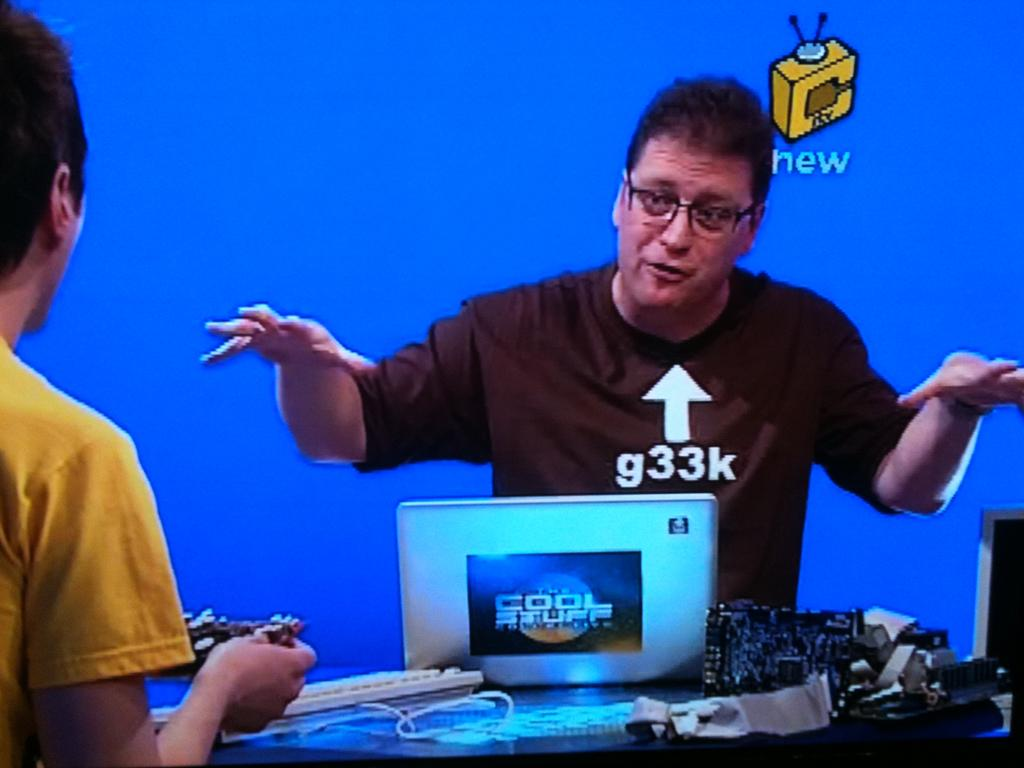Provide a one-sentence caption for the provided image. A man with the words g33k pointing at him talks to someone holding a video game controller. 